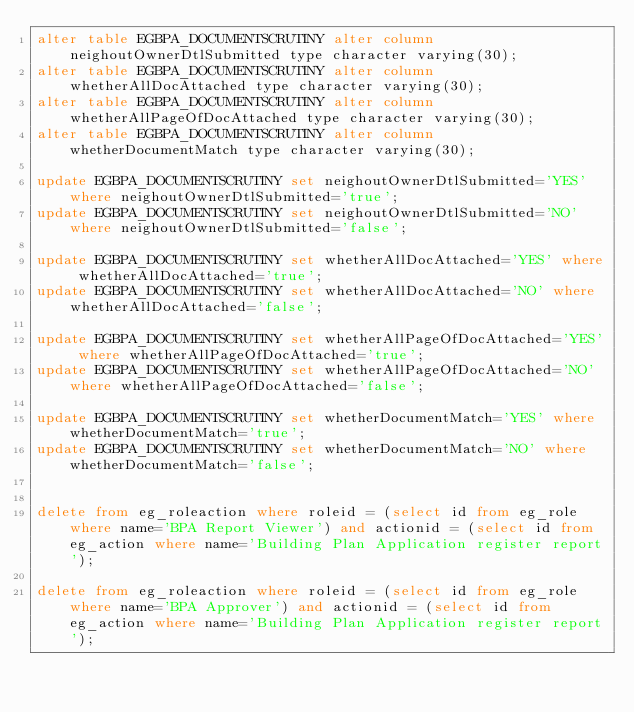Convert code to text. <code><loc_0><loc_0><loc_500><loc_500><_SQL_>alter table EGBPA_DOCUMENTSCRUTINY alter column neighoutOwnerDtlSubmitted type character varying(30);
alter table EGBPA_DOCUMENTSCRUTINY alter column whetherAllDocAttached type character varying(30);
alter table EGBPA_DOCUMENTSCRUTINY alter column whetherAllPageOfDocAttached type character varying(30);
alter table EGBPA_DOCUMENTSCRUTINY alter column whetherDocumentMatch type character varying(30);

update EGBPA_DOCUMENTSCRUTINY set neighoutOwnerDtlSubmitted='YES' where neighoutOwnerDtlSubmitted='true';
update EGBPA_DOCUMENTSCRUTINY set neighoutOwnerDtlSubmitted='NO' where neighoutOwnerDtlSubmitted='false';

update EGBPA_DOCUMENTSCRUTINY set whetherAllDocAttached='YES' where whetherAllDocAttached='true';
update EGBPA_DOCUMENTSCRUTINY set whetherAllDocAttached='NO' where whetherAllDocAttached='false';

update EGBPA_DOCUMENTSCRUTINY set whetherAllPageOfDocAttached='YES' where whetherAllPageOfDocAttached='true';
update EGBPA_DOCUMENTSCRUTINY set whetherAllPageOfDocAttached='NO' where whetherAllPageOfDocAttached='false';

update EGBPA_DOCUMENTSCRUTINY set whetherDocumentMatch='YES' where whetherDocumentMatch='true';
update EGBPA_DOCUMENTSCRUTINY set whetherDocumentMatch='NO' where whetherDocumentMatch='false';


delete from eg_roleaction where roleid = (select id from eg_role where name='BPA Report Viewer') and actionid = (select id from eg_action where name='Building Plan Application register report');

delete from eg_roleaction where roleid = (select id from eg_role where name='BPA Approver') and actionid = (select id from eg_action where name='Building Plan Application register report');
</code> 